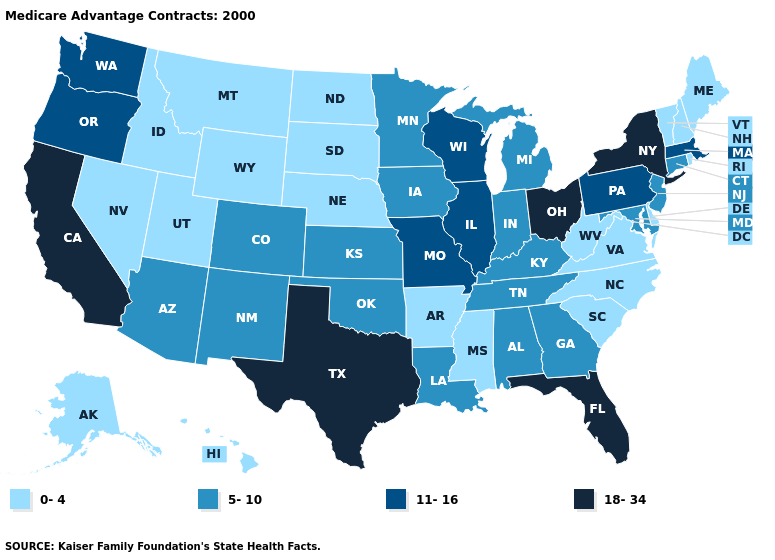What is the value of Maine?
Write a very short answer. 0-4. What is the value of Vermont?
Give a very brief answer. 0-4. Does Texas have the highest value in the USA?
Short answer required. Yes. Which states have the lowest value in the USA?
Write a very short answer. Alaska, Arkansas, Delaware, Hawaii, Idaho, Maine, Mississippi, Montana, North Carolina, North Dakota, Nebraska, New Hampshire, Nevada, Rhode Island, South Carolina, South Dakota, Utah, Virginia, Vermont, West Virginia, Wyoming. What is the value of Massachusetts?
Be succinct. 11-16. What is the value of Wyoming?
Be succinct. 0-4. What is the highest value in states that border Tennessee?
Keep it brief. 11-16. What is the highest value in states that border Texas?
Quick response, please. 5-10. What is the value of Virginia?
Write a very short answer. 0-4. What is the highest value in states that border Nevada?
Keep it brief. 18-34. Does Wisconsin have the highest value in the USA?
Answer briefly. No. Does the map have missing data?
Give a very brief answer. No. Name the states that have a value in the range 5-10?
Short answer required. Alabama, Arizona, Colorado, Connecticut, Georgia, Iowa, Indiana, Kansas, Kentucky, Louisiana, Maryland, Michigan, Minnesota, New Jersey, New Mexico, Oklahoma, Tennessee. Which states have the lowest value in the USA?
Keep it brief. Alaska, Arkansas, Delaware, Hawaii, Idaho, Maine, Mississippi, Montana, North Carolina, North Dakota, Nebraska, New Hampshire, Nevada, Rhode Island, South Carolina, South Dakota, Utah, Virginia, Vermont, West Virginia, Wyoming. Does the first symbol in the legend represent the smallest category?
Concise answer only. Yes. 